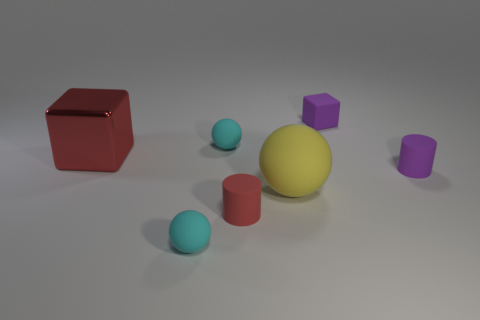There is a large rubber thing; what shape is it?
Offer a terse response. Sphere. Are there more metallic cubes in front of the large rubber sphere than tiny purple cubes in front of the small block?
Give a very brief answer. No. What number of other things are there of the same size as the purple cylinder?
Keep it short and to the point. 4. There is a object that is in front of the big metallic object and to the right of the large yellow rubber object; what is its material?
Give a very brief answer. Rubber. What material is the other small purple object that is the same shape as the metal thing?
Make the answer very short. Rubber. There is a sphere in front of the big object in front of the large shiny block; what number of small purple matte cylinders are in front of it?
Your answer should be compact. 0. Are there any other things that are the same color as the rubber cube?
Ensure brevity in your answer.  Yes. How many rubber things are both left of the yellow rubber object and in front of the big metal block?
Offer a terse response. 2. There is a cyan ball behind the yellow sphere; is it the same size as the cyan matte thing that is in front of the small purple cylinder?
Ensure brevity in your answer.  Yes. How many things are big matte objects to the right of the large block or large purple objects?
Provide a succinct answer. 1. 